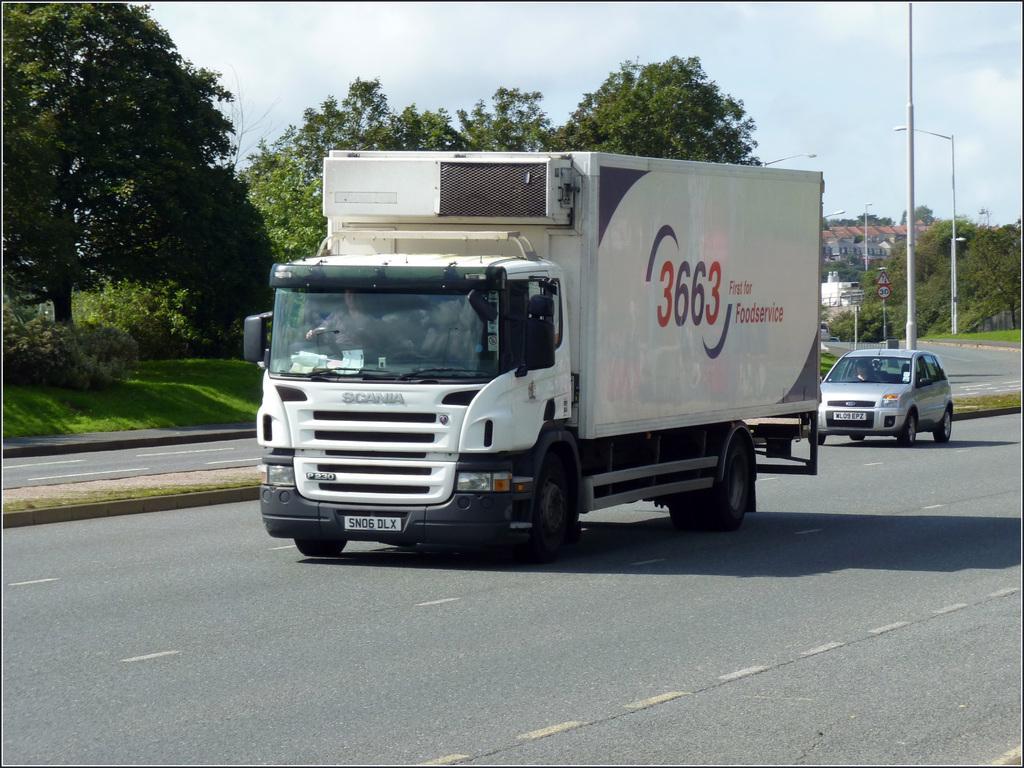In one or two sentences, can you explain what this image depicts? In this image I can see the road. I can see the vehicles with some text written on it. I can see the poles. In the background, I can see the trees, buildings and clouds in the sky. 